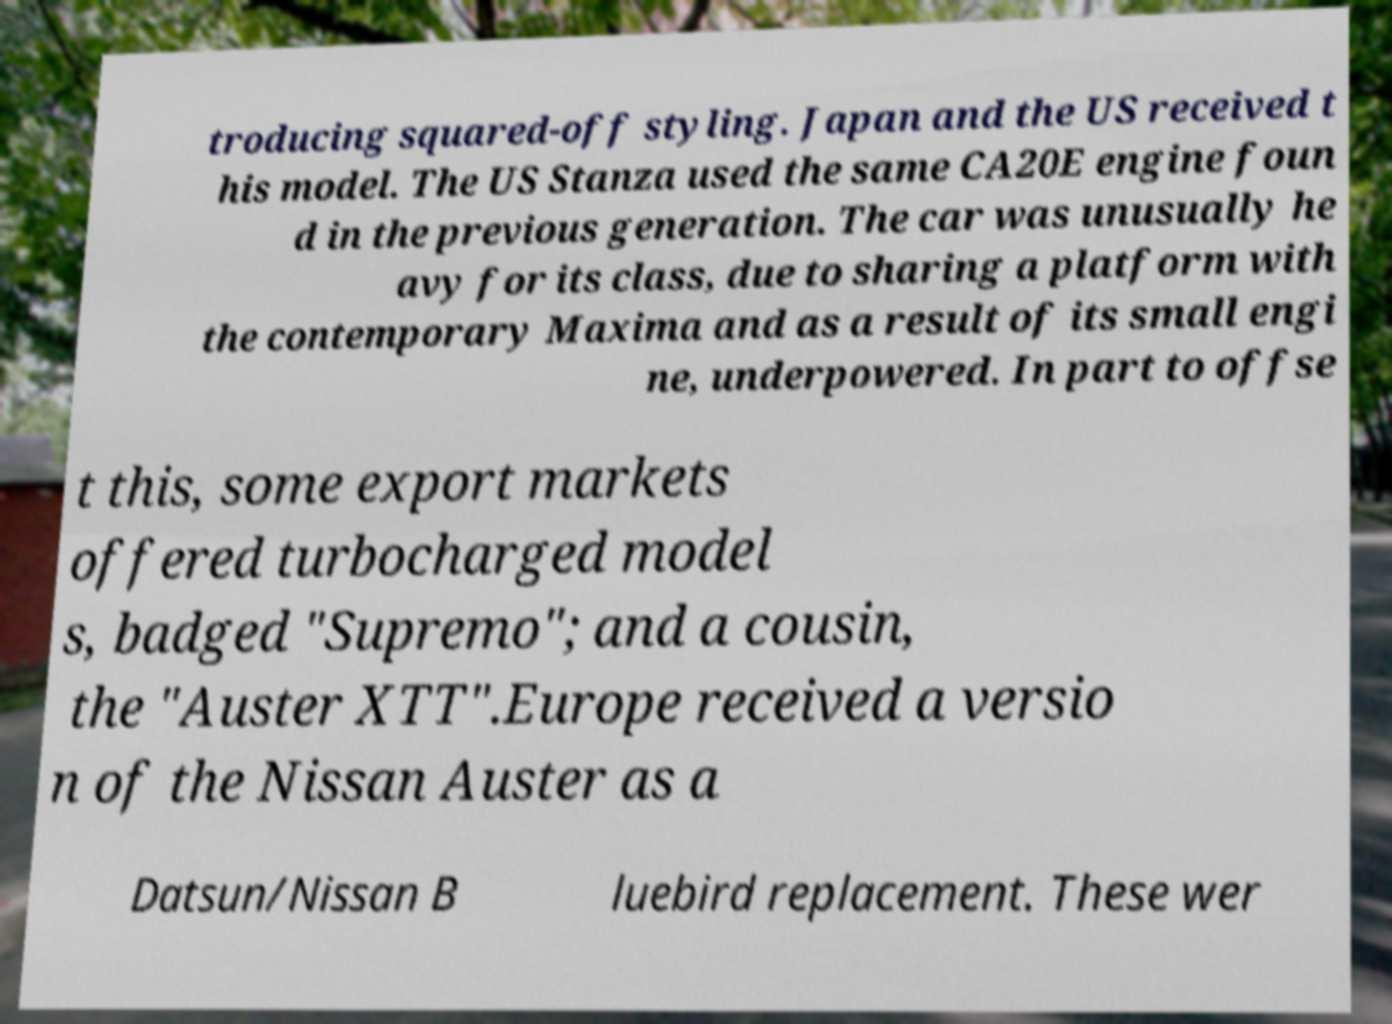For documentation purposes, I need the text within this image transcribed. Could you provide that? troducing squared-off styling. Japan and the US received t his model. The US Stanza used the same CA20E engine foun d in the previous generation. The car was unusually he avy for its class, due to sharing a platform with the contemporary Maxima and as a result of its small engi ne, underpowered. In part to offse t this, some export markets offered turbocharged model s, badged "Supremo"; and a cousin, the "Auster XTT".Europe received a versio n of the Nissan Auster as a Datsun/Nissan B luebird replacement. These wer 